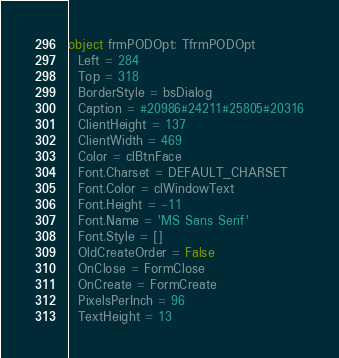<code> <loc_0><loc_0><loc_500><loc_500><_Pascal_>object frmPODOpt: TfrmPODOpt
  Left = 284
  Top = 318
  BorderStyle = bsDialog
  Caption = #20986#24211#25805#20316
  ClientHeight = 137
  ClientWidth = 469
  Color = clBtnFace
  Font.Charset = DEFAULT_CHARSET
  Font.Color = clWindowText
  Font.Height = -11
  Font.Name = 'MS Sans Serif'
  Font.Style = []
  OldCreateOrder = False
  OnClose = FormClose
  OnCreate = FormCreate
  PixelsPerInch = 96
  TextHeight = 13</code> 